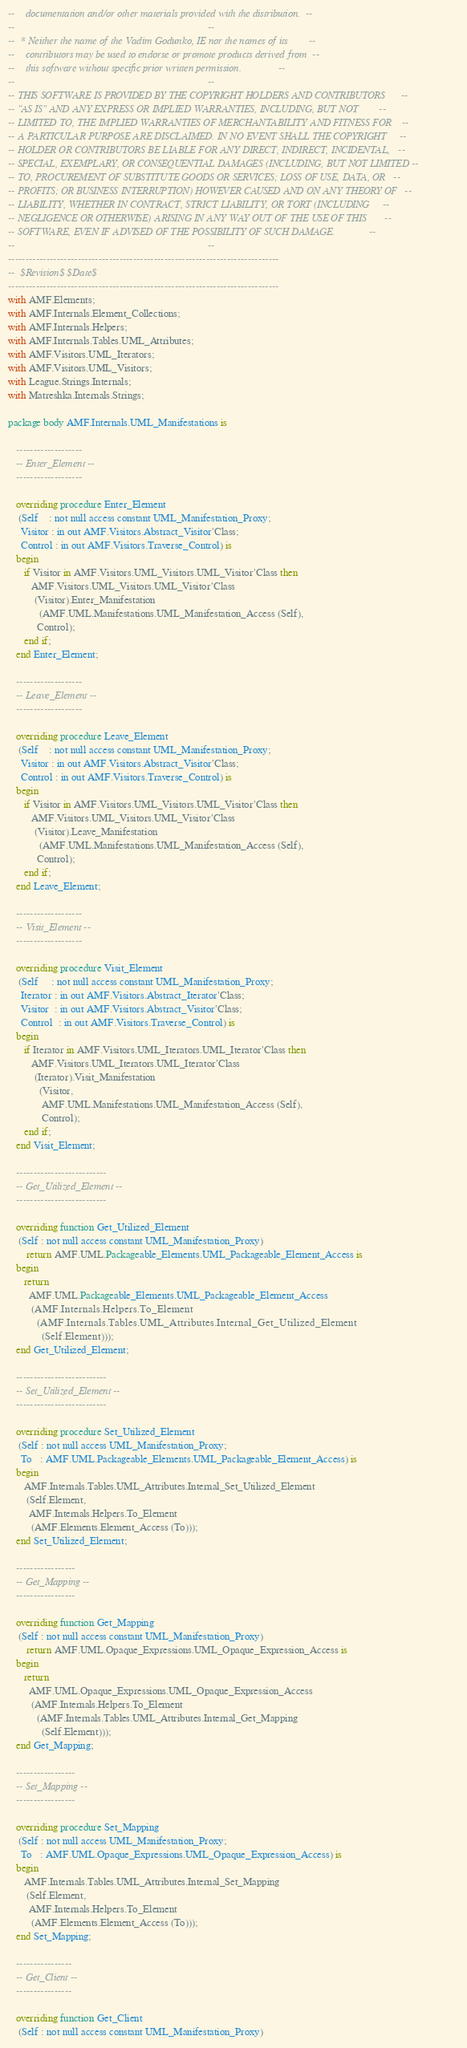<code> <loc_0><loc_0><loc_500><loc_500><_Ada_>--    documentation and/or other materials provided with the distribution.  --
--                                                                          --
--  * Neither the name of the Vadim Godunko, IE nor the names of its        --
--    contributors may be used to endorse or promote products derived from  --
--    this software without specific prior written permission.              --
--                                                                          --
-- THIS SOFTWARE IS PROVIDED BY THE COPYRIGHT HOLDERS AND CONTRIBUTORS      --
-- "AS IS" AND ANY EXPRESS OR IMPLIED WARRANTIES, INCLUDING, BUT NOT        --
-- LIMITED TO, THE IMPLIED WARRANTIES OF MERCHANTABILITY AND FITNESS FOR    --
-- A PARTICULAR PURPOSE ARE DISCLAIMED. IN NO EVENT SHALL THE COPYRIGHT     --
-- HOLDER OR CONTRIBUTORS BE LIABLE FOR ANY DIRECT, INDIRECT, INCIDENTAL,   --
-- SPECIAL, EXEMPLARY, OR CONSEQUENTIAL DAMAGES (INCLUDING, BUT NOT LIMITED --
-- TO, PROCUREMENT OF SUBSTITUTE GOODS OR SERVICES; LOSS OF USE, DATA, OR   --
-- PROFITS; OR BUSINESS INTERRUPTION) HOWEVER CAUSED AND ON ANY THEORY OF   --
-- LIABILITY, WHETHER IN CONTRACT, STRICT LIABILITY, OR TORT (INCLUDING     --
-- NEGLIGENCE OR OTHERWISE) ARISING IN ANY WAY OUT OF THE USE OF THIS       --
-- SOFTWARE, EVEN IF ADVISED OF THE POSSIBILITY OF SUCH DAMAGE.             --
--                                                                          --
------------------------------------------------------------------------------
--  $Revision$ $Date$
------------------------------------------------------------------------------
with AMF.Elements;
with AMF.Internals.Element_Collections;
with AMF.Internals.Helpers;
with AMF.Internals.Tables.UML_Attributes;
with AMF.Visitors.UML_Iterators;
with AMF.Visitors.UML_Visitors;
with League.Strings.Internals;
with Matreshka.Internals.Strings;

package body AMF.Internals.UML_Manifestations is

   -------------------
   -- Enter_Element --
   -------------------

   overriding procedure Enter_Element
    (Self    : not null access constant UML_Manifestation_Proxy;
     Visitor : in out AMF.Visitors.Abstract_Visitor'Class;
     Control : in out AMF.Visitors.Traverse_Control) is
   begin
      if Visitor in AMF.Visitors.UML_Visitors.UML_Visitor'Class then
         AMF.Visitors.UML_Visitors.UML_Visitor'Class
          (Visitor).Enter_Manifestation
            (AMF.UML.Manifestations.UML_Manifestation_Access (Self),
           Control);
      end if;
   end Enter_Element;

   -------------------
   -- Leave_Element --
   -------------------

   overriding procedure Leave_Element
    (Self    : not null access constant UML_Manifestation_Proxy;
     Visitor : in out AMF.Visitors.Abstract_Visitor'Class;
     Control : in out AMF.Visitors.Traverse_Control) is
   begin
      if Visitor in AMF.Visitors.UML_Visitors.UML_Visitor'Class then
         AMF.Visitors.UML_Visitors.UML_Visitor'Class
          (Visitor).Leave_Manifestation
            (AMF.UML.Manifestations.UML_Manifestation_Access (Self),
           Control);
      end if;
   end Leave_Element;

   -------------------
   -- Visit_Element --
   -------------------

   overriding procedure Visit_Element
    (Self     : not null access constant UML_Manifestation_Proxy;
     Iterator : in out AMF.Visitors.Abstract_Iterator'Class;
     Visitor  : in out AMF.Visitors.Abstract_Visitor'Class;
     Control  : in out AMF.Visitors.Traverse_Control) is
   begin
      if Iterator in AMF.Visitors.UML_Iterators.UML_Iterator'Class then
         AMF.Visitors.UML_Iterators.UML_Iterator'Class
          (Iterator).Visit_Manifestation
            (Visitor,
             AMF.UML.Manifestations.UML_Manifestation_Access (Self),
             Control);
      end if;
   end Visit_Element;

   --------------------------
   -- Get_Utilized_Element --
   --------------------------

   overriding function Get_Utilized_Element
    (Self : not null access constant UML_Manifestation_Proxy)
       return AMF.UML.Packageable_Elements.UML_Packageable_Element_Access is
   begin
      return
        AMF.UML.Packageable_Elements.UML_Packageable_Element_Access
         (AMF.Internals.Helpers.To_Element
           (AMF.Internals.Tables.UML_Attributes.Internal_Get_Utilized_Element
             (Self.Element)));
   end Get_Utilized_Element;

   --------------------------
   -- Set_Utilized_Element --
   --------------------------

   overriding procedure Set_Utilized_Element
    (Self : not null access UML_Manifestation_Proxy;
     To   : AMF.UML.Packageable_Elements.UML_Packageable_Element_Access) is
   begin
      AMF.Internals.Tables.UML_Attributes.Internal_Set_Utilized_Element
       (Self.Element,
        AMF.Internals.Helpers.To_Element
         (AMF.Elements.Element_Access (To)));
   end Set_Utilized_Element;

   -----------------
   -- Get_Mapping --
   -----------------

   overriding function Get_Mapping
    (Self : not null access constant UML_Manifestation_Proxy)
       return AMF.UML.Opaque_Expressions.UML_Opaque_Expression_Access is
   begin
      return
        AMF.UML.Opaque_Expressions.UML_Opaque_Expression_Access
         (AMF.Internals.Helpers.To_Element
           (AMF.Internals.Tables.UML_Attributes.Internal_Get_Mapping
             (Self.Element)));
   end Get_Mapping;

   -----------------
   -- Set_Mapping --
   -----------------

   overriding procedure Set_Mapping
    (Self : not null access UML_Manifestation_Proxy;
     To   : AMF.UML.Opaque_Expressions.UML_Opaque_Expression_Access) is
   begin
      AMF.Internals.Tables.UML_Attributes.Internal_Set_Mapping
       (Self.Element,
        AMF.Internals.Helpers.To_Element
         (AMF.Elements.Element_Access (To)));
   end Set_Mapping;

   ----------------
   -- Get_Client --
   ----------------

   overriding function Get_Client
    (Self : not null access constant UML_Manifestation_Proxy)</code> 